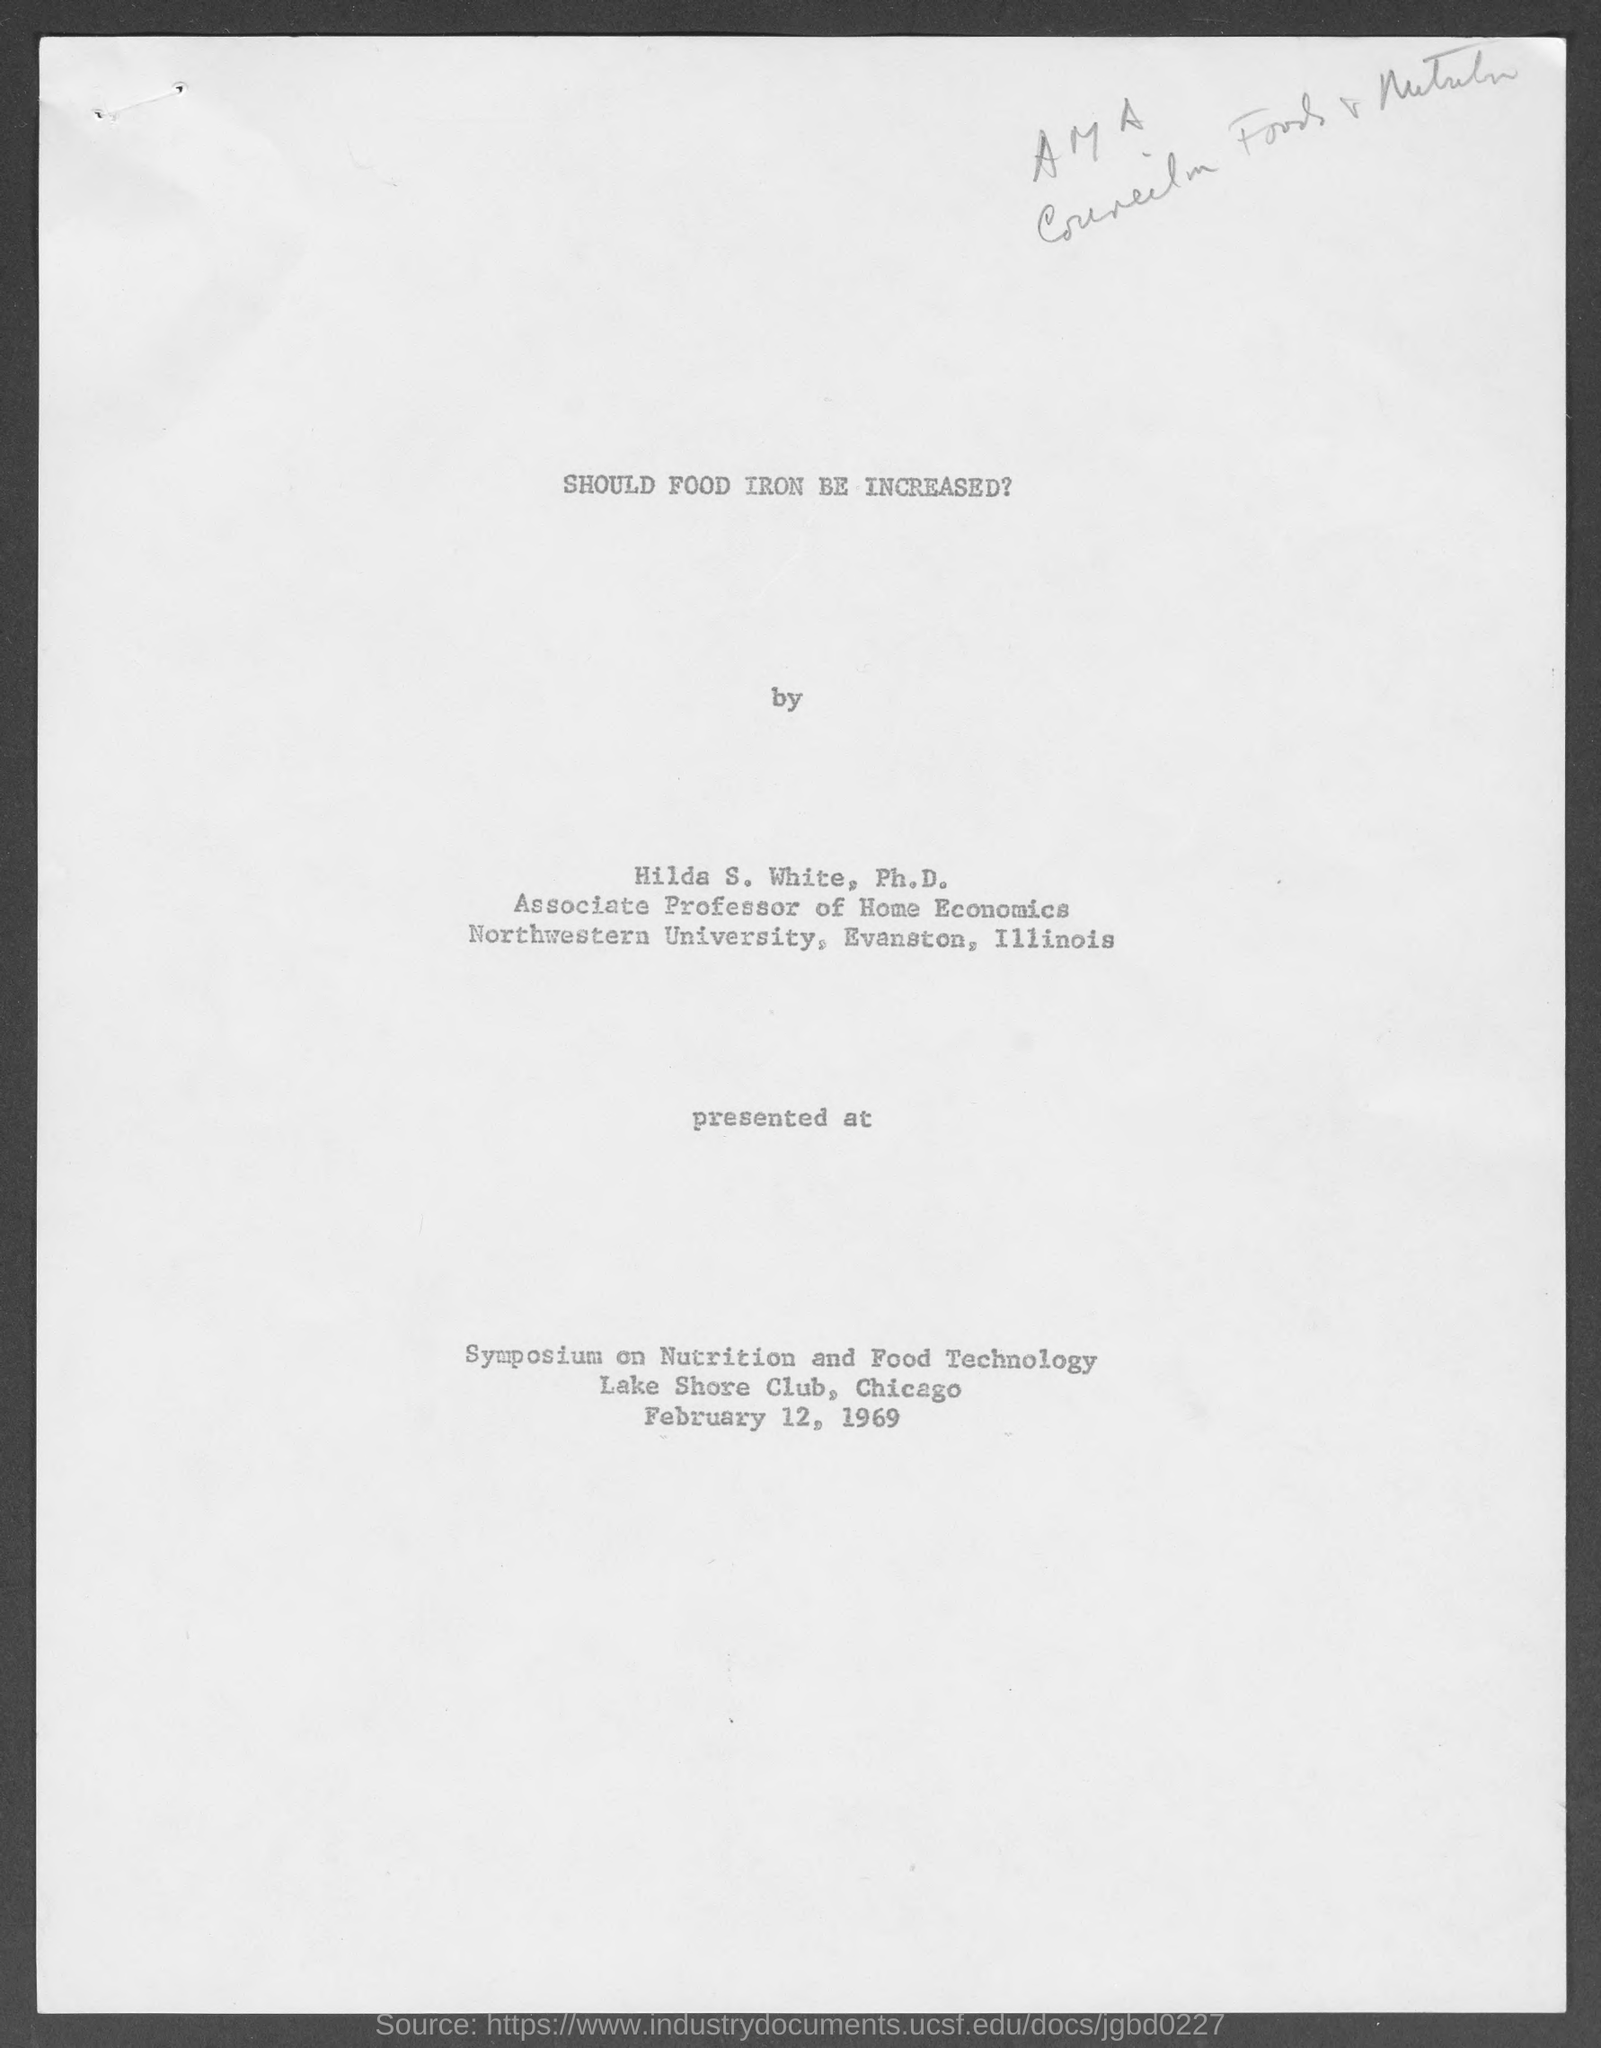When was the Symposium on Nutrition and Food Technology held?
Offer a terse response. February 12, 1969. Where was the Symposium on Nutrition and Food Technology held?
Offer a terse response. Lake Shore Club, Chicago. 